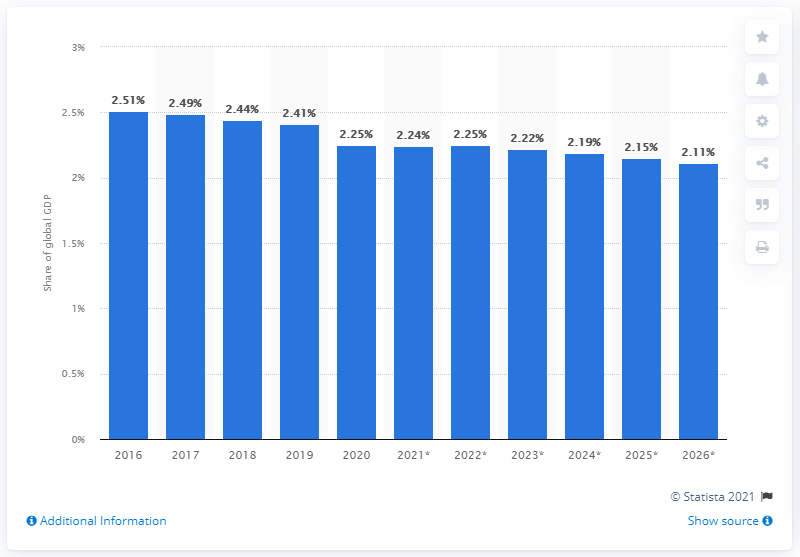Highlight a few significant elements in this photo. In 2020, the United Kingdom's share of global GDP was 2.25%. 